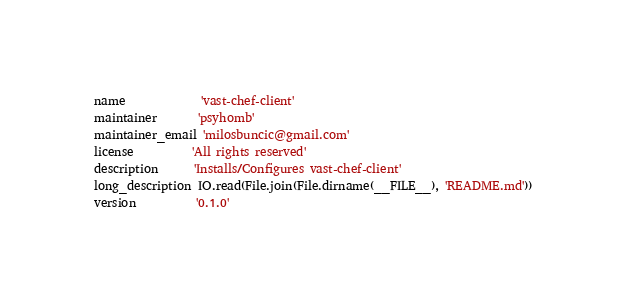<code> <loc_0><loc_0><loc_500><loc_500><_Ruby_>name             'vast-chef-client'
maintainer       'psyhomb'
maintainer_email 'milosbuncic@gmail.com'
license          'All rights reserved'
description      'Installs/Configures vast-chef-client'
long_description IO.read(File.join(File.dirname(__FILE__), 'README.md'))
version          '0.1.0'
</code> 